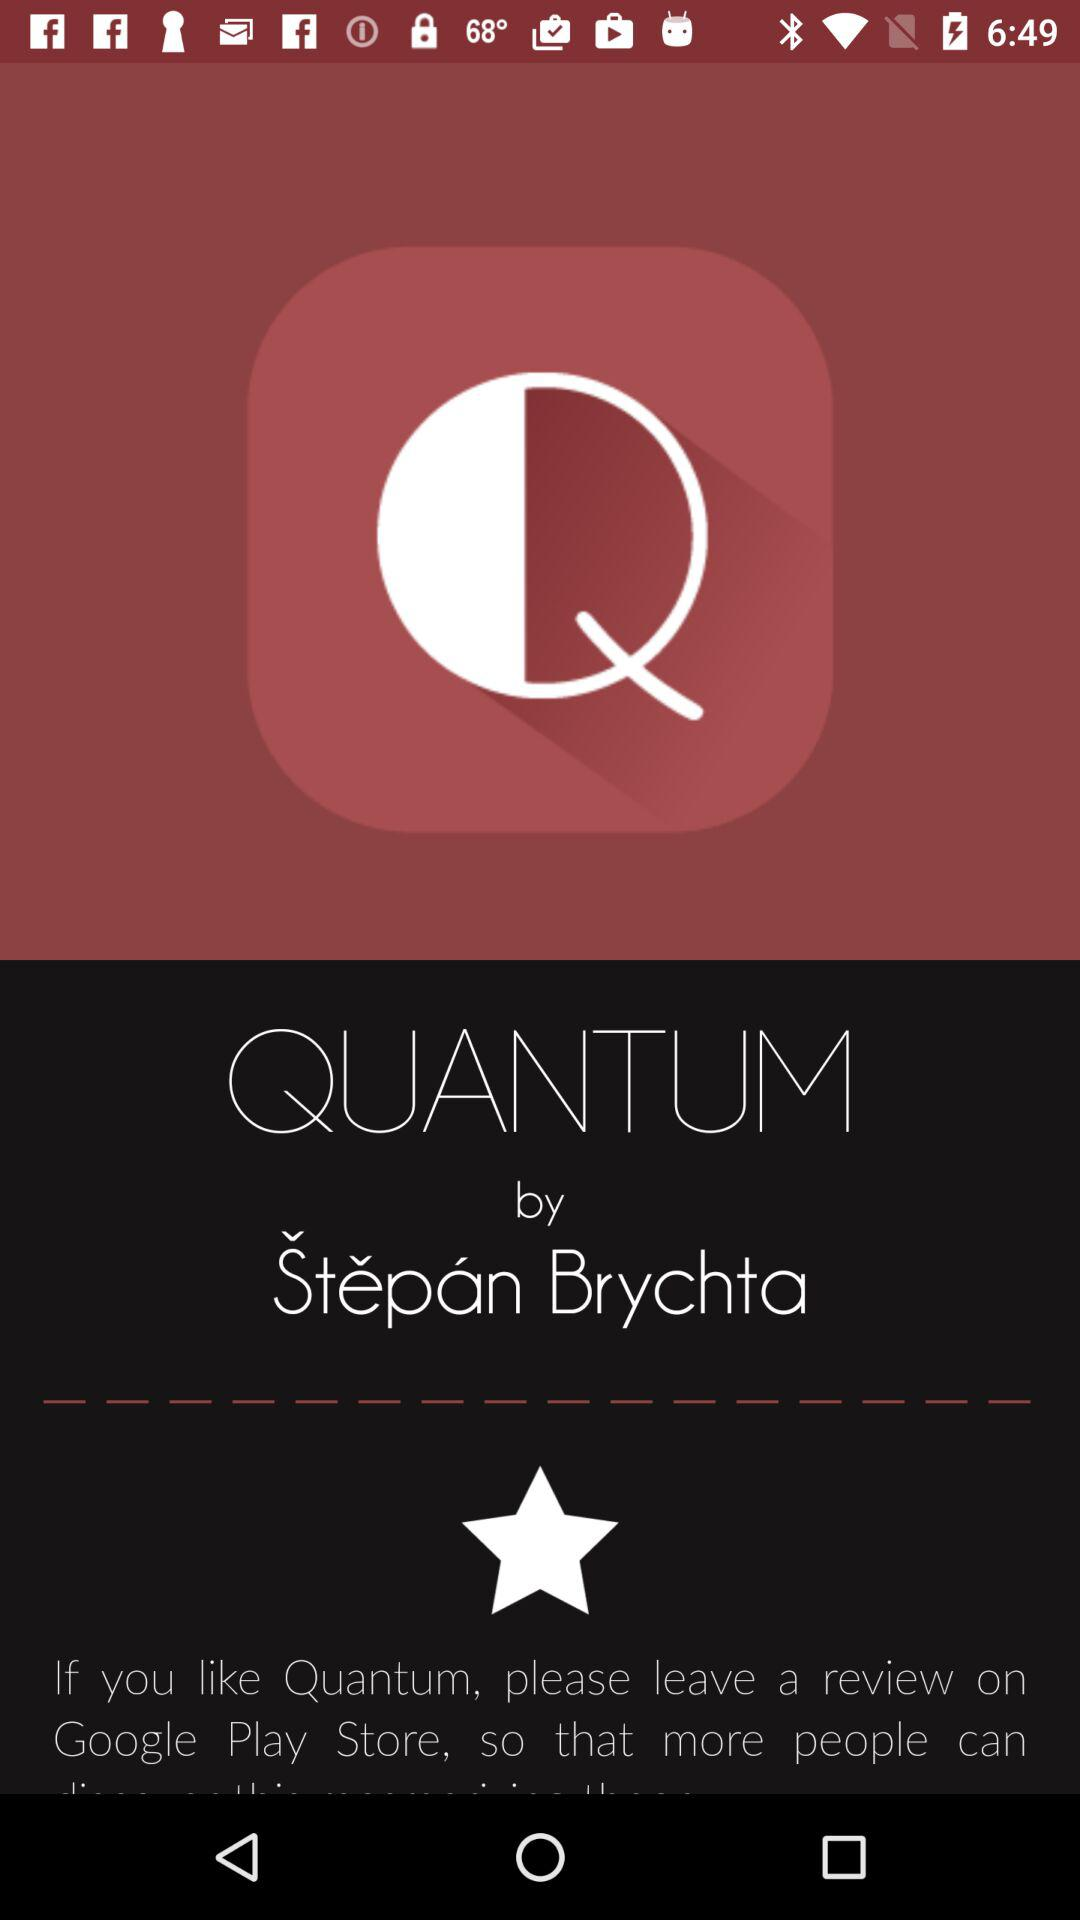What is the application name? The application name is "QUANTUM". 